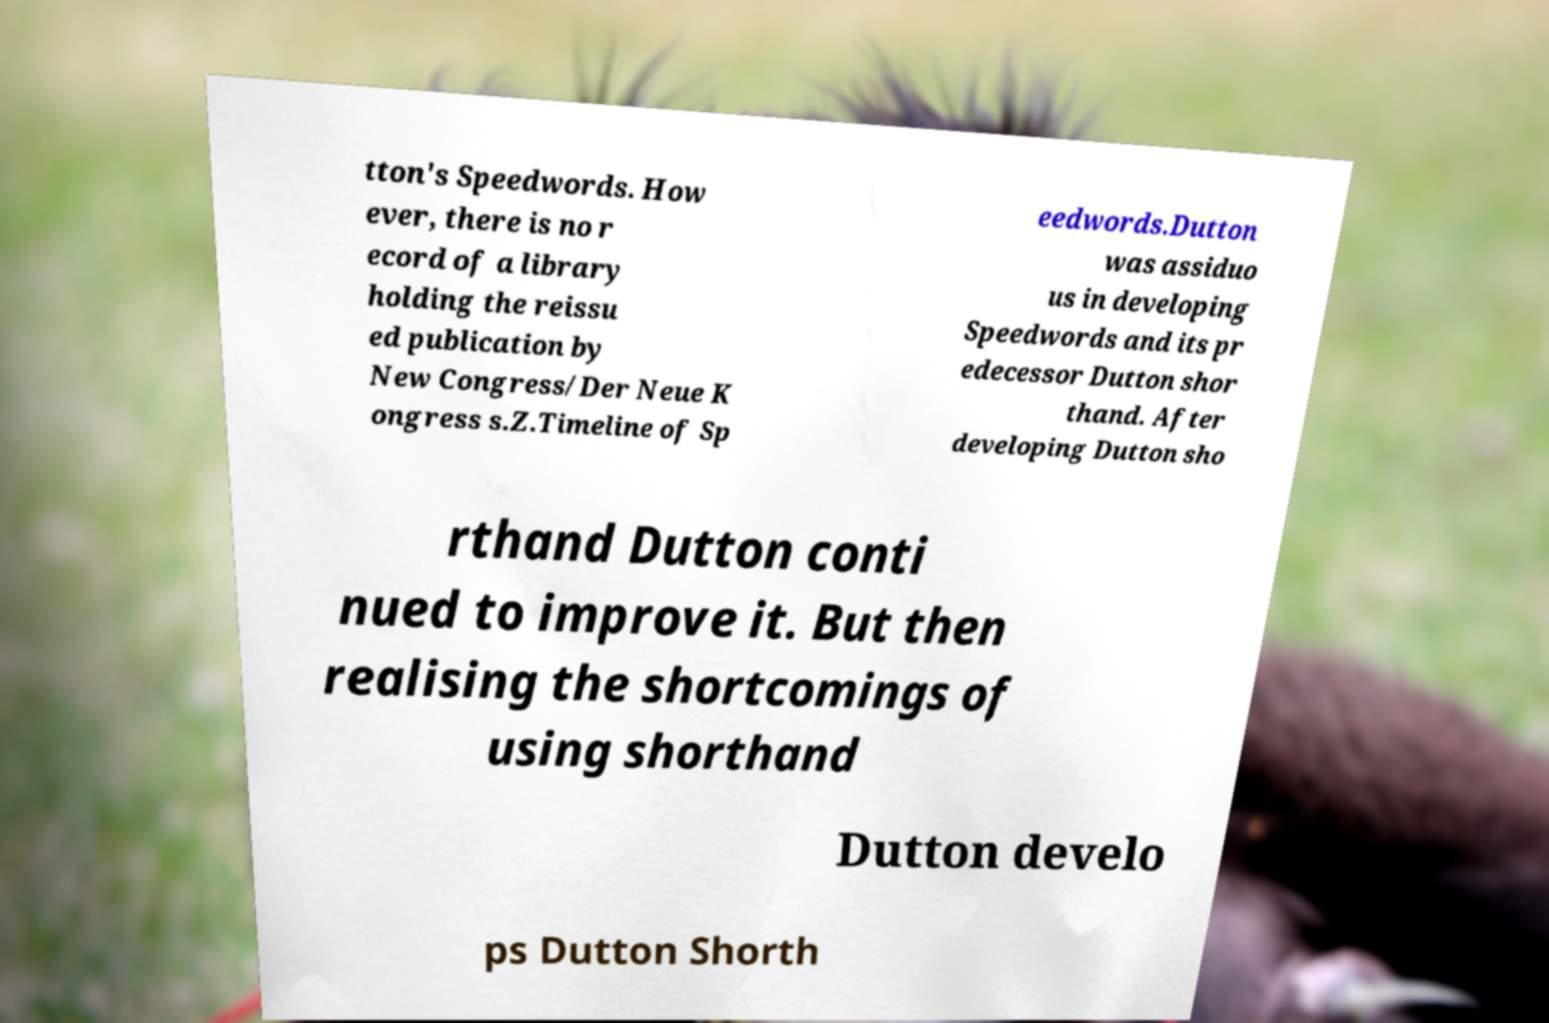I need the written content from this picture converted into text. Can you do that? tton's Speedwords. How ever, there is no r ecord of a library holding the reissu ed publication by New Congress/Der Neue K ongress s.Z.Timeline of Sp eedwords.Dutton was assiduo us in developing Speedwords and its pr edecessor Dutton shor thand. After developing Dutton sho rthand Dutton conti nued to improve it. But then realising the shortcomings of using shorthand Dutton develo ps Dutton Shorth 